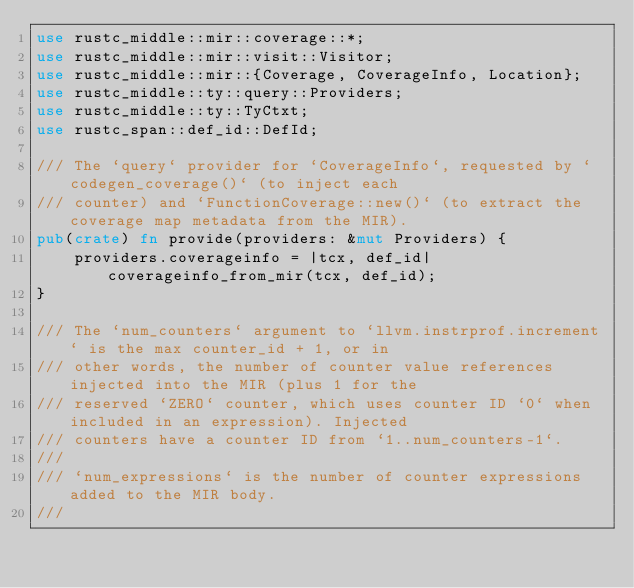<code> <loc_0><loc_0><loc_500><loc_500><_Rust_>use rustc_middle::mir::coverage::*;
use rustc_middle::mir::visit::Visitor;
use rustc_middle::mir::{Coverage, CoverageInfo, Location};
use rustc_middle::ty::query::Providers;
use rustc_middle::ty::TyCtxt;
use rustc_span::def_id::DefId;

/// The `query` provider for `CoverageInfo`, requested by `codegen_coverage()` (to inject each
/// counter) and `FunctionCoverage::new()` (to extract the coverage map metadata from the MIR).
pub(crate) fn provide(providers: &mut Providers) {
    providers.coverageinfo = |tcx, def_id| coverageinfo_from_mir(tcx, def_id);
}

/// The `num_counters` argument to `llvm.instrprof.increment` is the max counter_id + 1, or in
/// other words, the number of counter value references injected into the MIR (plus 1 for the
/// reserved `ZERO` counter, which uses counter ID `0` when included in an expression). Injected
/// counters have a counter ID from `1..num_counters-1`.
///
/// `num_expressions` is the number of counter expressions added to the MIR body.
///</code> 